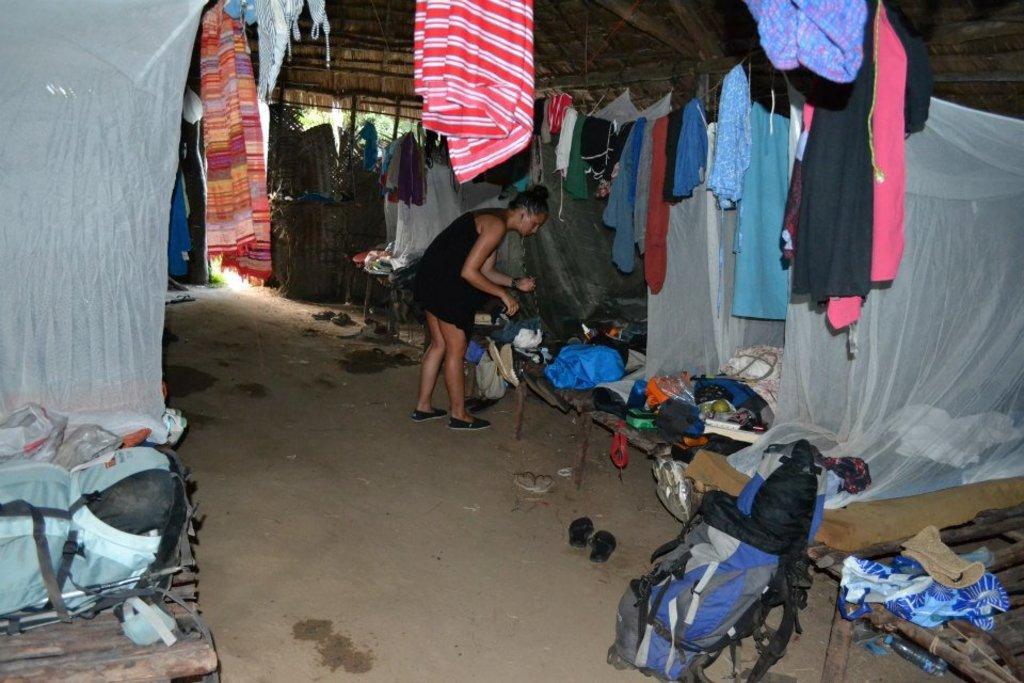Could you give a brief overview of what you see in this image? A woman is standing in a house. There are some cuts on either side. There are mosquito nets on the cots. There are clothes hanged from the ropes tied to the roof. There are clothes scattered on the cots. There are bags and other articles on the ground. 